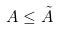Convert formula to latex. <formula><loc_0><loc_0><loc_500><loc_500>A \leq \tilde { A }</formula> 